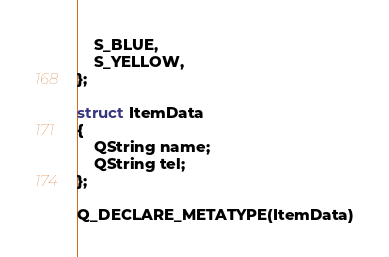Convert code to text. <code><loc_0><loc_0><loc_500><loc_500><_C_>	S_BLUE,
	S_YELLOW,
};

struct ItemData
{
	QString name;
	QString tel;
};

Q_DECLARE_METATYPE(ItemData)
</code> 